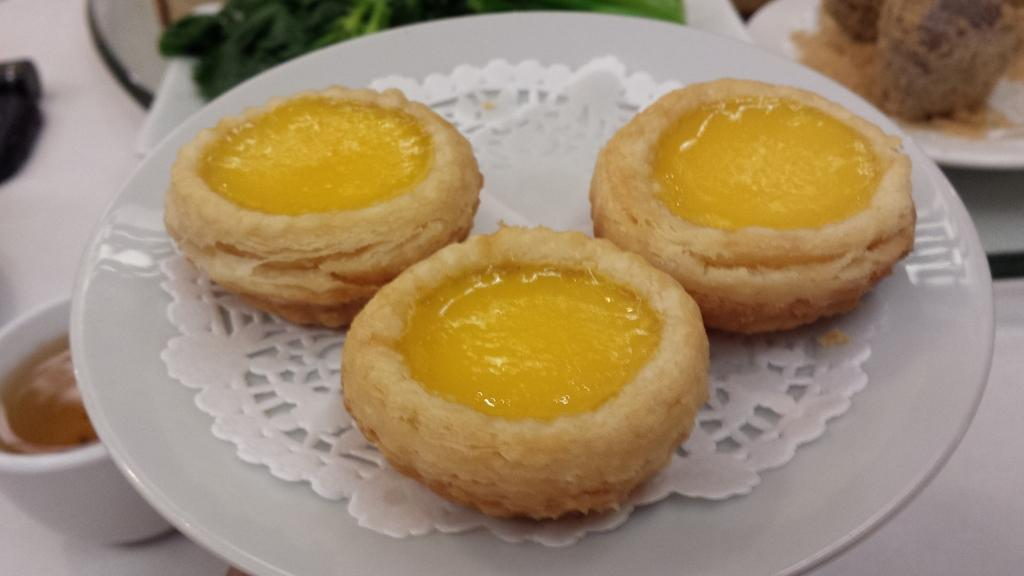What type of plates are the food items placed on in the image? The food items are placed on white color plates in the image. What type of beverage containers are visible in the image? There are cups in the image. What color is the surface on which the objects are placed in the image? The other objects are placed on a white color surface in the image. What type of deer can be seen on the canvas in the image? There is no canvas or deer present in the image. 